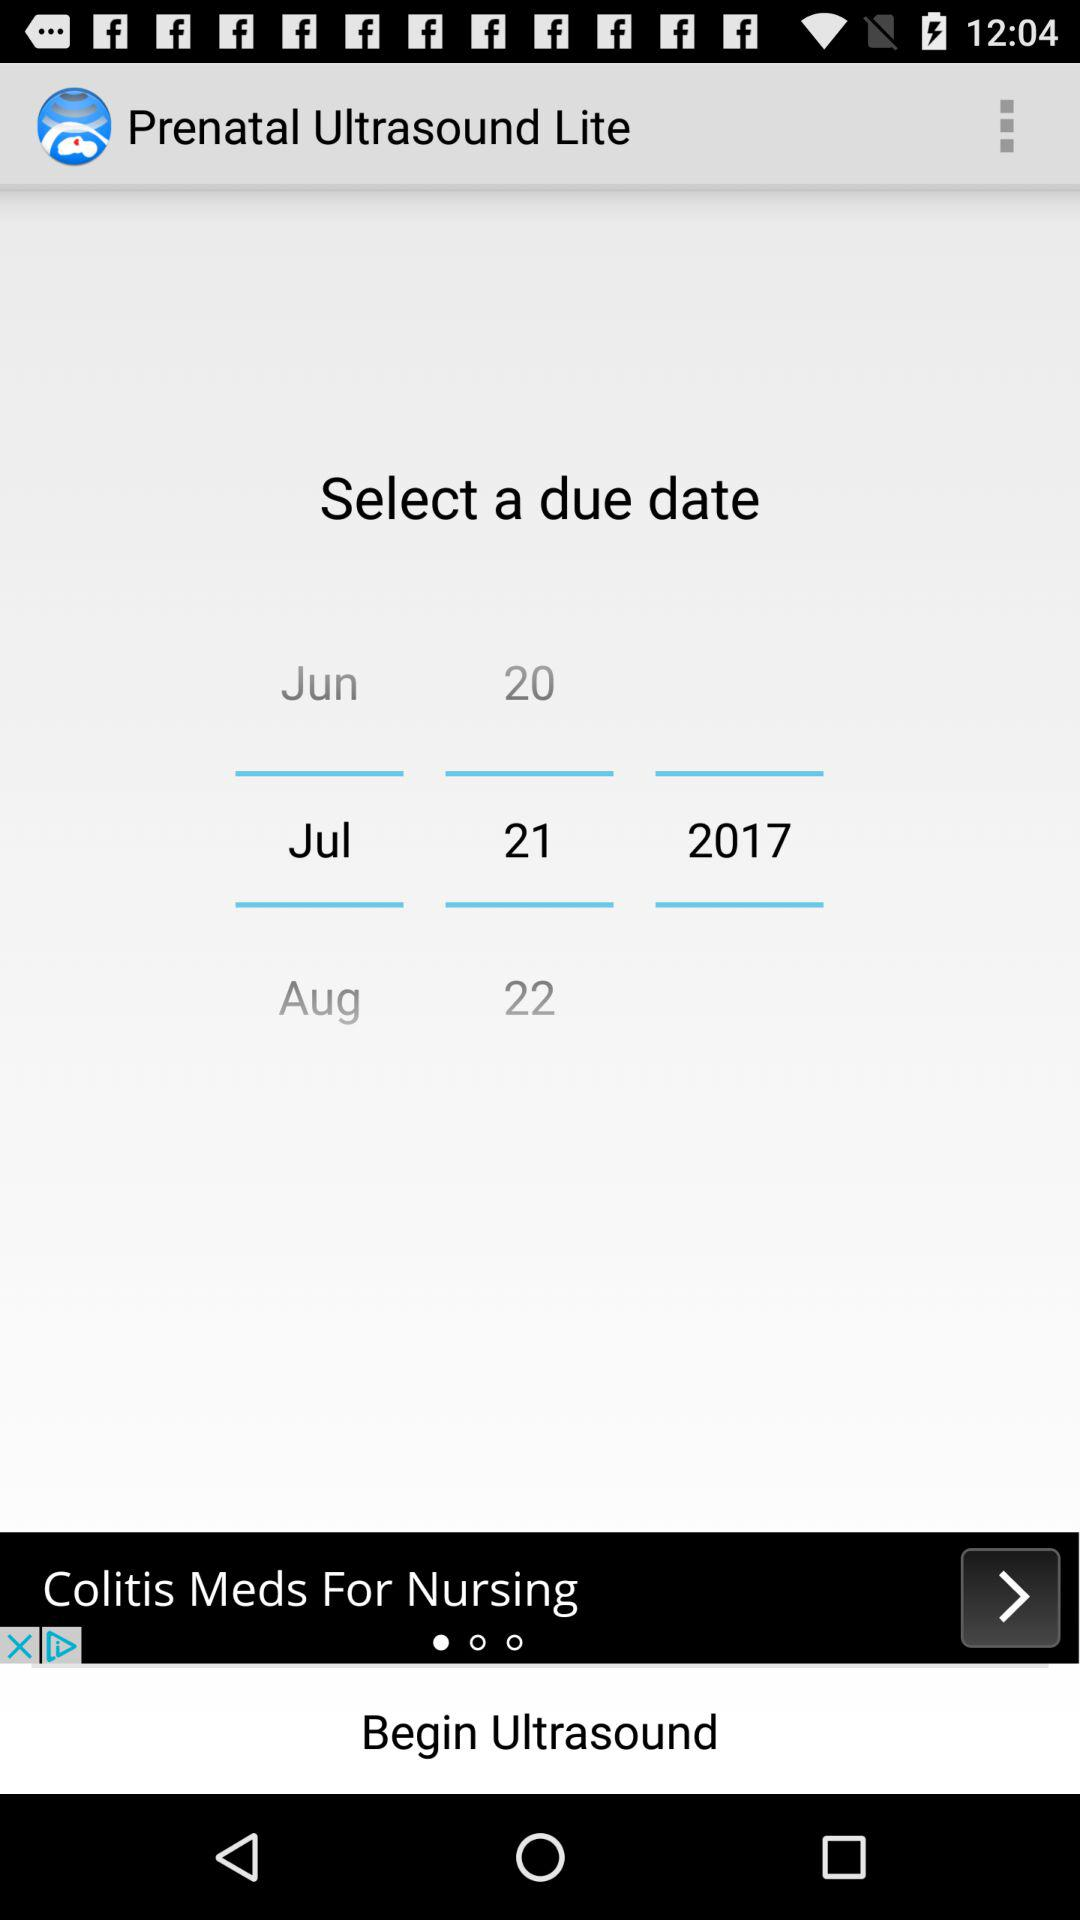What's the selected due date? The selected due date is July 21, 2017. 